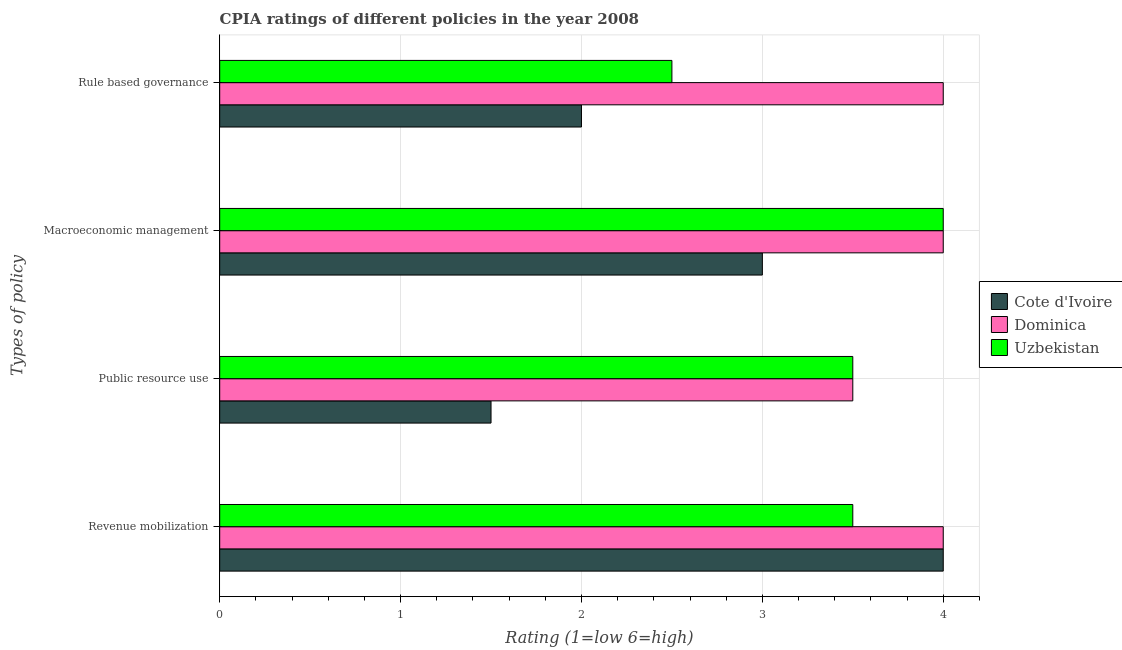Are the number of bars on each tick of the Y-axis equal?
Your answer should be compact. Yes. How many bars are there on the 3rd tick from the top?
Your response must be concise. 3. How many bars are there on the 2nd tick from the bottom?
Offer a terse response. 3. What is the label of the 3rd group of bars from the top?
Provide a short and direct response. Public resource use. Across all countries, what is the maximum cpia rating of public resource use?
Give a very brief answer. 3.5. Across all countries, what is the minimum cpia rating of rule based governance?
Your answer should be very brief. 2. In which country was the cpia rating of macroeconomic management maximum?
Your response must be concise. Dominica. In which country was the cpia rating of macroeconomic management minimum?
Your response must be concise. Cote d'Ivoire. What is the total cpia rating of revenue mobilization in the graph?
Provide a succinct answer. 11.5. What is the difference between the cpia rating of rule based governance in Cote d'Ivoire and the cpia rating of revenue mobilization in Dominica?
Your answer should be compact. -2. What is the average cpia rating of macroeconomic management per country?
Make the answer very short. 3.67. In how many countries, is the cpia rating of rule based governance greater than 2.8 ?
Your answer should be compact. 1. What is the ratio of the cpia rating of rule based governance in Cote d'Ivoire to that in Dominica?
Provide a succinct answer. 0.5. Is the cpia rating of revenue mobilization in Cote d'Ivoire less than that in Dominica?
Offer a very short reply. No. Is the difference between the cpia rating of macroeconomic management in Uzbekistan and Cote d'Ivoire greater than the difference between the cpia rating of rule based governance in Uzbekistan and Cote d'Ivoire?
Provide a succinct answer. Yes. What does the 2nd bar from the top in Public resource use represents?
Offer a terse response. Dominica. What does the 3rd bar from the bottom in Macroeconomic management represents?
Offer a very short reply. Uzbekistan. How many countries are there in the graph?
Give a very brief answer. 3. Does the graph contain grids?
Give a very brief answer. Yes. How many legend labels are there?
Keep it short and to the point. 3. What is the title of the graph?
Your response must be concise. CPIA ratings of different policies in the year 2008. What is the label or title of the X-axis?
Ensure brevity in your answer.  Rating (1=low 6=high). What is the label or title of the Y-axis?
Offer a very short reply. Types of policy. What is the Rating (1=low 6=high) in Cote d'Ivoire in Revenue mobilization?
Offer a very short reply. 4. What is the Rating (1=low 6=high) of Dominica in Revenue mobilization?
Offer a terse response. 4. What is the Rating (1=low 6=high) in Uzbekistan in Revenue mobilization?
Provide a succinct answer. 3.5. What is the Rating (1=low 6=high) of Cote d'Ivoire in Public resource use?
Offer a terse response. 1.5. What is the Rating (1=low 6=high) of Dominica in Public resource use?
Give a very brief answer. 3.5. What is the Rating (1=low 6=high) in Uzbekistan in Public resource use?
Provide a succinct answer. 3.5. What is the Rating (1=low 6=high) of Uzbekistan in Macroeconomic management?
Provide a short and direct response. 4. What is the Rating (1=low 6=high) in Cote d'Ivoire in Rule based governance?
Offer a very short reply. 2. What is the Rating (1=low 6=high) in Dominica in Rule based governance?
Your response must be concise. 4. What is the Rating (1=low 6=high) in Uzbekistan in Rule based governance?
Your answer should be very brief. 2.5. Across all Types of policy, what is the maximum Rating (1=low 6=high) of Dominica?
Offer a very short reply. 4. Across all Types of policy, what is the maximum Rating (1=low 6=high) of Uzbekistan?
Ensure brevity in your answer.  4. Across all Types of policy, what is the minimum Rating (1=low 6=high) of Cote d'Ivoire?
Your answer should be very brief. 1.5. Across all Types of policy, what is the minimum Rating (1=low 6=high) in Uzbekistan?
Make the answer very short. 2.5. What is the total Rating (1=low 6=high) in Cote d'Ivoire in the graph?
Offer a very short reply. 10.5. What is the difference between the Rating (1=low 6=high) of Dominica in Revenue mobilization and that in Public resource use?
Your answer should be very brief. 0.5. What is the difference between the Rating (1=low 6=high) of Cote d'Ivoire in Revenue mobilization and that in Macroeconomic management?
Offer a very short reply. 1. What is the difference between the Rating (1=low 6=high) of Dominica in Revenue mobilization and that in Macroeconomic management?
Your answer should be compact. 0. What is the difference between the Rating (1=low 6=high) of Uzbekistan in Revenue mobilization and that in Macroeconomic management?
Offer a very short reply. -0.5. What is the difference between the Rating (1=low 6=high) in Cote d'Ivoire in Public resource use and that in Macroeconomic management?
Keep it short and to the point. -1.5. What is the difference between the Rating (1=low 6=high) in Dominica in Public resource use and that in Macroeconomic management?
Ensure brevity in your answer.  -0.5. What is the difference between the Rating (1=low 6=high) of Uzbekistan in Public resource use and that in Macroeconomic management?
Offer a terse response. -0.5. What is the difference between the Rating (1=low 6=high) in Cote d'Ivoire in Macroeconomic management and that in Rule based governance?
Your answer should be compact. 1. What is the difference between the Rating (1=low 6=high) of Dominica in Macroeconomic management and that in Rule based governance?
Offer a very short reply. 0. What is the difference between the Rating (1=low 6=high) of Uzbekistan in Macroeconomic management and that in Rule based governance?
Your answer should be very brief. 1.5. What is the difference between the Rating (1=low 6=high) in Cote d'Ivoire in Revenue mobilization and the Rating (1=low 6=high) in Uzbekistan in Macroeconomic management?
Your answer should be very brief. 0. What is the difference between the Rating (1=low 6=high) of Dominica in Revenue mobilization and the Rating (1=low 6=high) of Uzbekistan in Macroeconomic management?
Your answer should be very brief. 0. What is the difference between the Rating (1=low 6=high) of Cote d'Ivoire in Revenue mobilization and the Rating (1=low 6=high) of Dominica in Rule based governance?
Give a very brief answer. 0. What is the difference between the Rating (1=low 6=high) in Cote d'Ivoire in Revenue mobilization and the Rating (1=low 6=high) in Uzbekistan in Rule based governance?
Your answer should be very brief. 1.5. What is the difference between the Rating (1=low 6=high) of Dominica in Revenue mobilization and the Rating (1=low 6=high) of Uzbekistan in Rule based governance?
Provide a short and direct response. 1.5. What is the difference between the Rating (1=low 6=high) in Dominica in Public resource use and the Rating (1=low 6=high) in Uzbekistan in Macroeconomic management?
Offer a very short reply. -0.5. What is the difference between the Rating (1=low 6=high) in Cote d'Ivoire in Public resource use and the Rating (1=low 6=high) in Dominica in Rule based governance?
Your response must be concise. -2.5. What is the difference between the Rating (1=low 6=high) in Dominica in Macroeconomic management and the Rating (1=low 6=high) in Uzbekistan in Rule based governance?
Ensure brevity in your answer.  1.5. What is the average Rating (1=low 6=high) of Cote d'Ivoire per Types of policy?
Make the answer very short. 2.62. What is the average Rating (1=low 6=high) of Dominica per Types of policy?
Provide a short and direct response. 3.88. What is the average Rating (1=low 6=high) in Uzbekistan per Types of policy?
Provide a short and direct response. 3.38. What is the difference between the Rating (1=low 6=high) of Cote d'Ivoire and Rating (1=low 6=high) of Dominica in Revenue mobilization?
Make the answer very short. 0. What is the difference between the Rating (1=low 6=high) in Cote d'Ivoire and Rating (1=low 6=high) in Uzbekistan in Revenue mobilization?
Your answer should be very brief. 0.5. What is the difference between the Rating (1=low 6=high) of Cote d'Ivoire and Rating (1=low 6=high) of Uzbekistan in Public resource use?
Offer a very short reply. -2. What is the difference between the Rating (1=low 6=high) in Cote d'Ivoire and Rating (1=low 6=high) in Uzbekistan in Rule based governance?
Give a very brief answer. -0.5. What is the difference between the Rating (1=low 6=high) of Dominica and Rating (1=low 6=high) of Uzbekistan in Rule based governance?
Your response must be concise. 1.5. What is the ratio of the Rating (1=low 6=high) of Cote d'Ivoire in Revenue mobilization to that in Public resource use?
Provide a short and direct response. 2.67. What is the ratio of the Rating (1=low 6=high) of Uzbekistan in Revenue mobilization to that in Public resource use?
Make the answer very short. 1. What is the ratio of the Rating (1=low 6=high) in Cote d'Ivoire in Revenue mobilization to that in Macroeconomic management?
Give a very brief answer. 1.33. What is the ratio of the Rating (1=low 6=high) of Dominica in Revenue mobilization to that in Rule based governance?
Make the answer very short. 1. What is the ratio of the Rating (1=low 6=high) in Uzbekistan in Revenue mobilization to that in Rule based governance?
Your response must be concise. 1.4. What is the ratio of the Rating (1=low 6=high) of Cote d'Ivoire in Public resource use to that in Macroeconomic management?
Your answer should be very brief. 0.5. What is the ratio of the Rating (1=low 6=high) in Dominica in Public resource use to that in Macroeconomic management?
Make the answer very short. 0.88. What is the difference between the highest and the second highest Rating (1=low 6=high) in Cote d'Ivoire?
Provide a short and direct response. 1. What is the difference between the highest and the second highest Rating (1=low 6=high) of Dominica?
Your response must be concise. 0. What is the difference between the highest and the second highest Rating (1=low 6=high) of Uzbekistan?
Provide a succinct answer. 0.5. What is the difference between the highest and the lowest Rating (1=low 6=high) of Dominica?
Make the answer very short. 0.5. What is the difference between the highest and the lowest Rating (1=low 6=high) in Uzbekistan?
Provide a succinct answer. 1.5. 